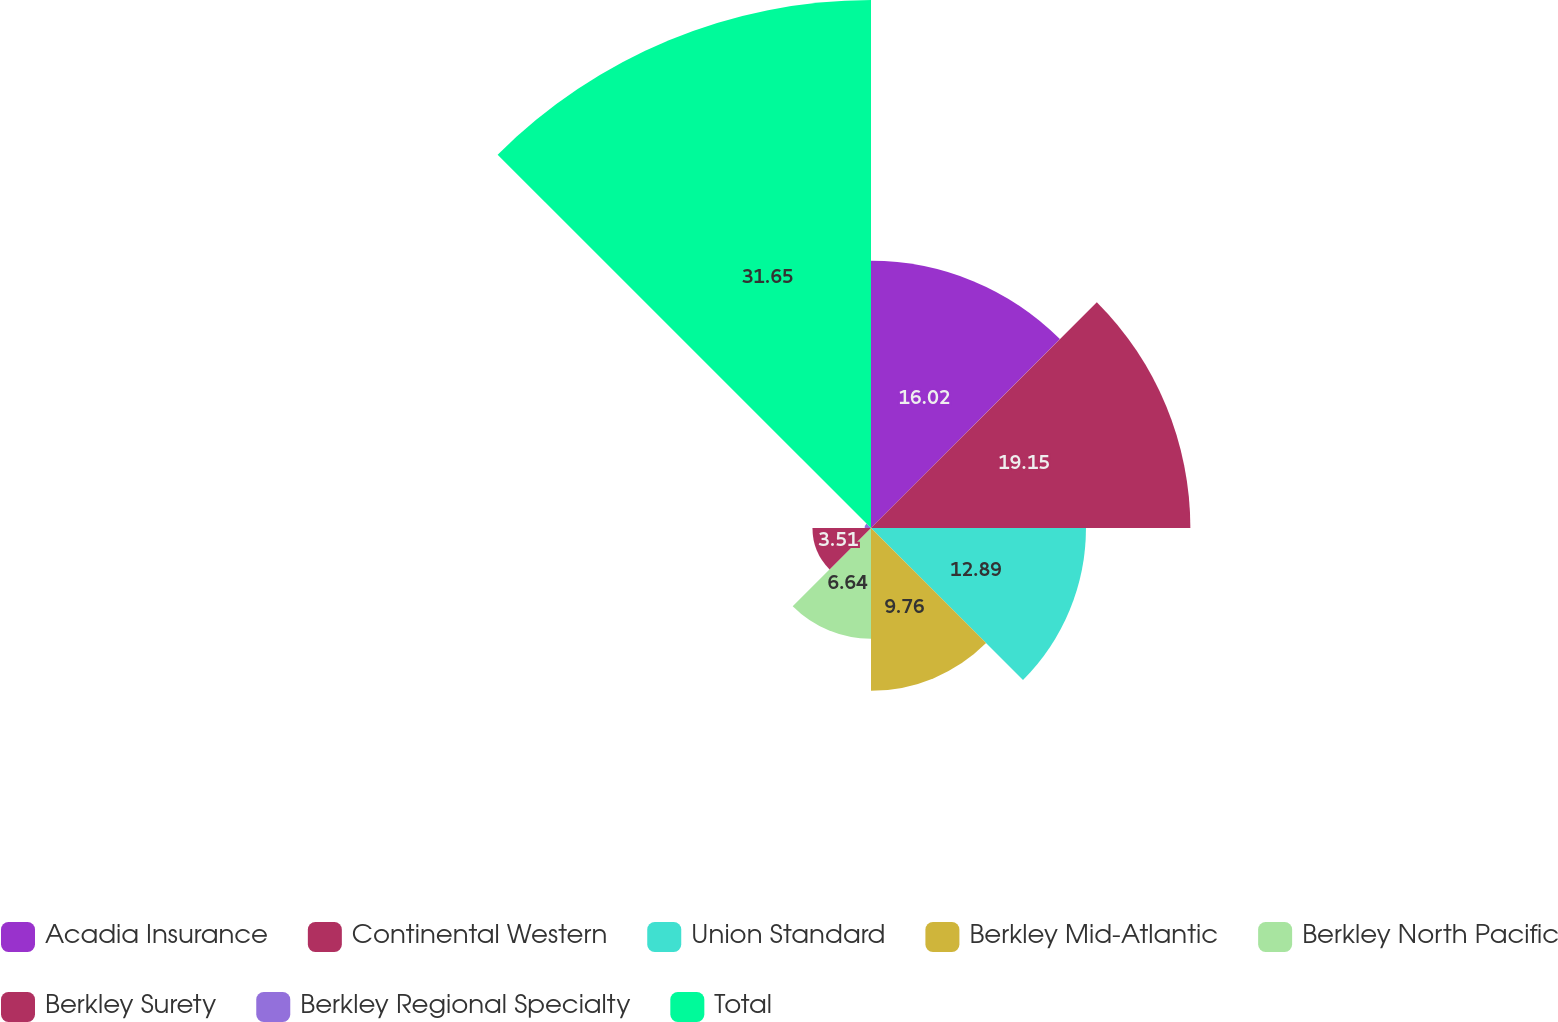<chart> <loc_0><loc_0><loc_500><loc_500><pie_chart><fcel>Acadia Insurance<fcel>Continental Western<fcel>Union Standard<fcel>Berkley Mid-Atlantic<fcel>Berkley North Pacific<fcel>Berkley Surety<fcel>Berkley Regional Specialty<fcel>Total<nl><fcel>16.02%<fcel>19.15%<fcel>12.89%<fcel>9.76%<fcel>6.64%<fcel>3.51%<fcel>0.38%<fcel>31.66%<nl></chart> 